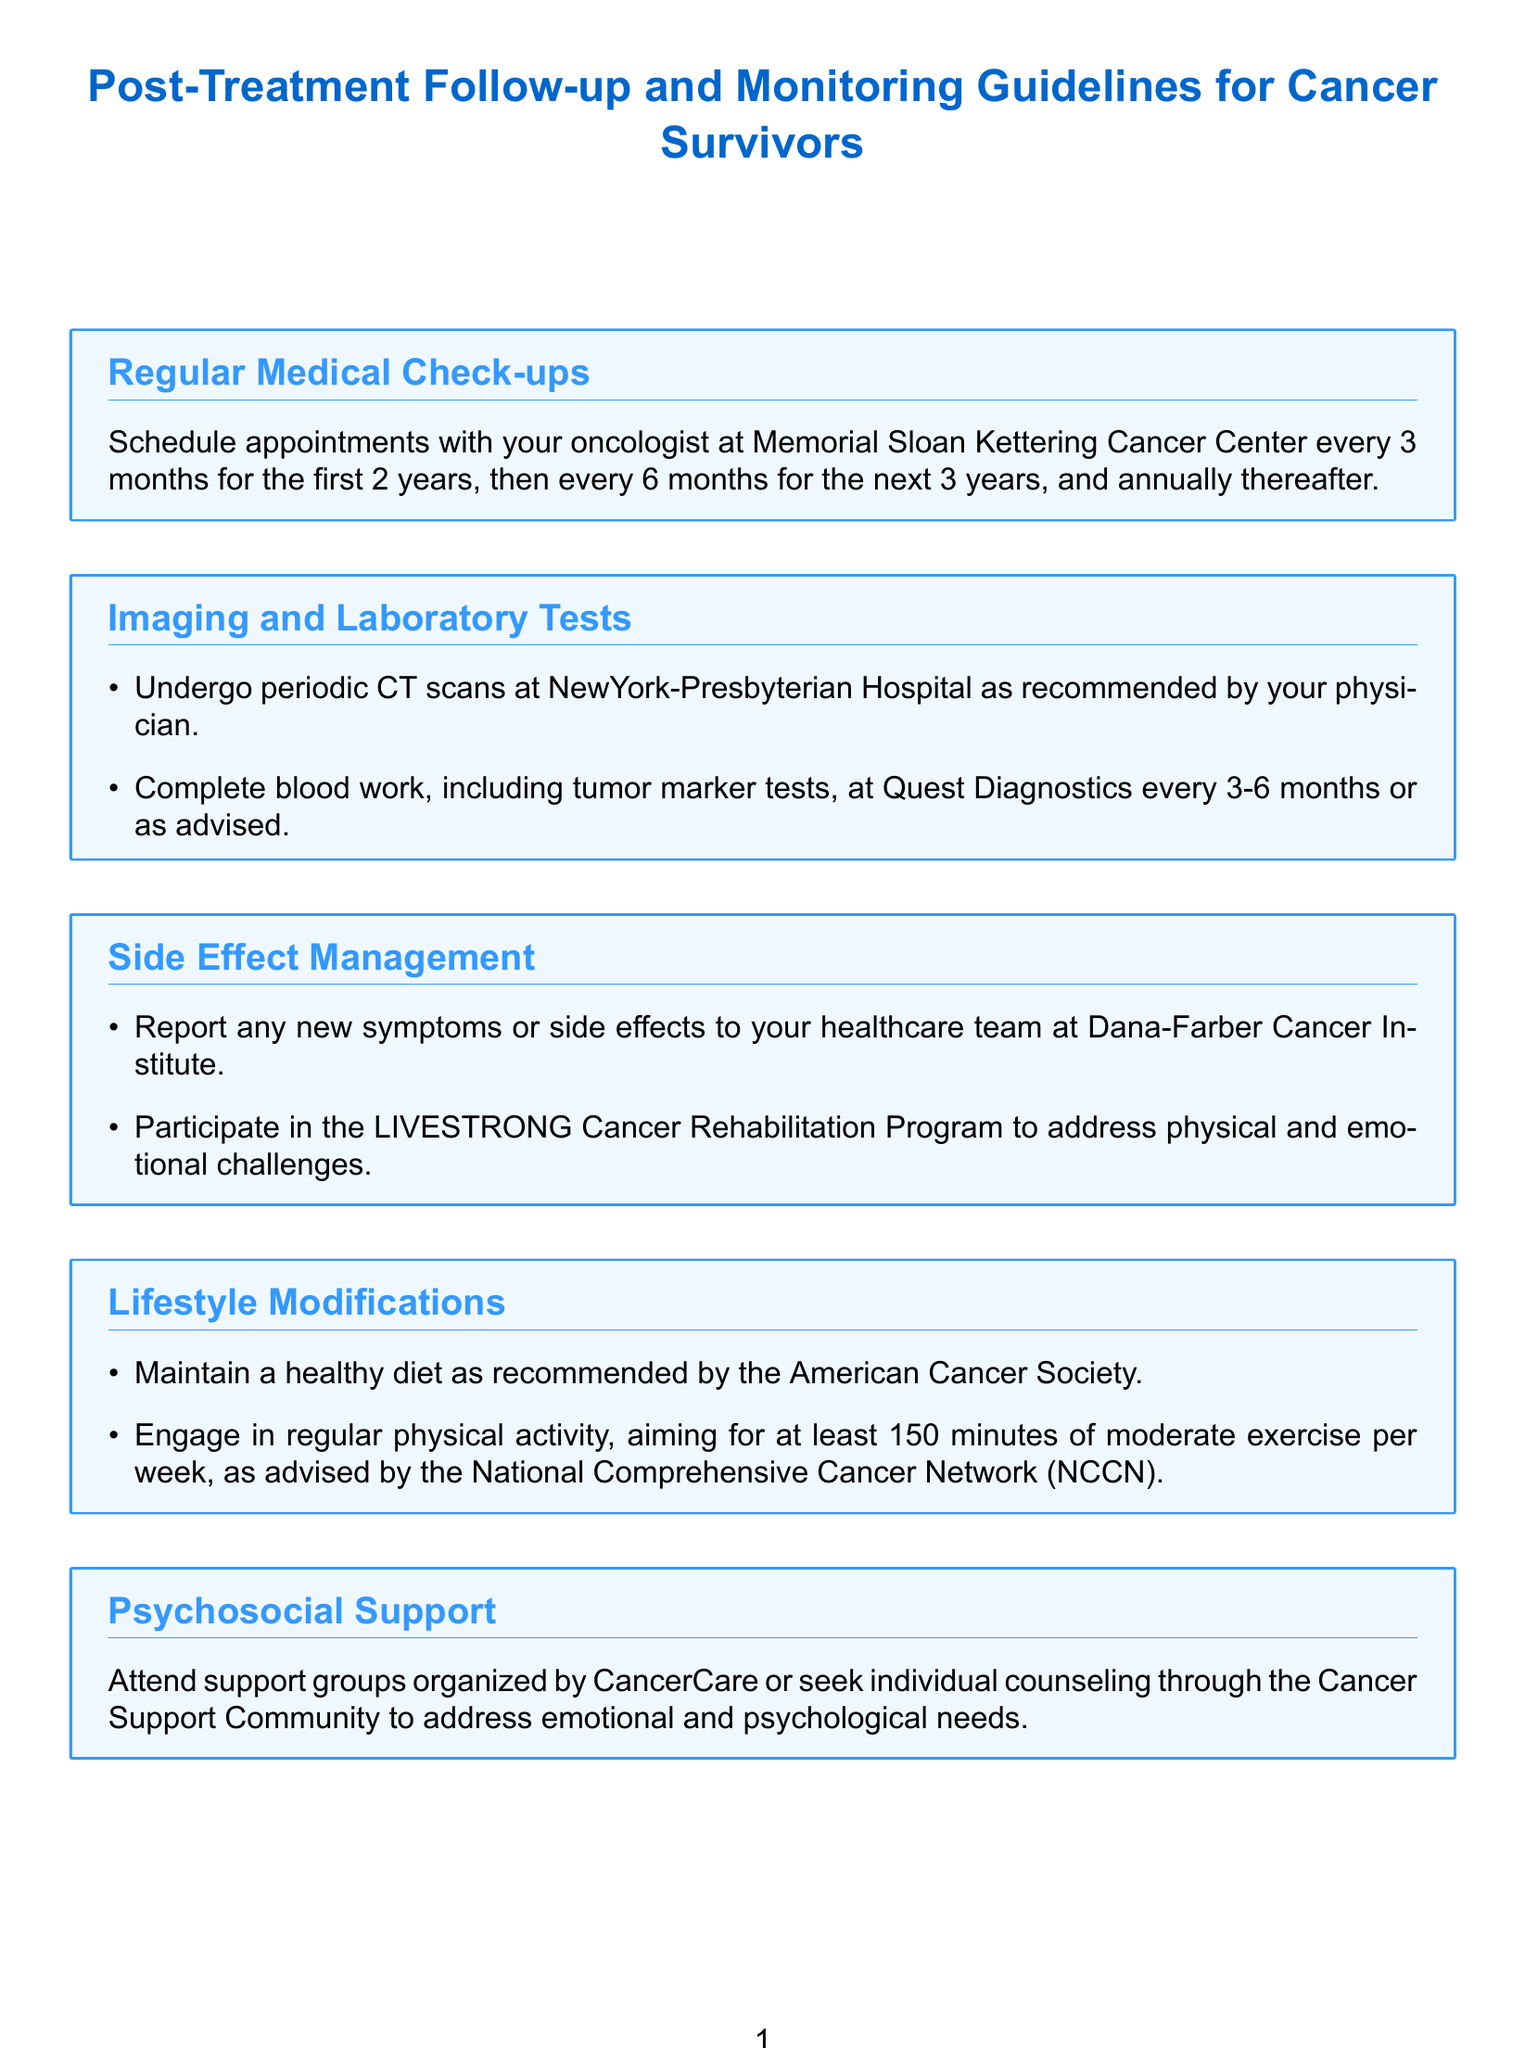What is the recommended frequency for medical check-ups in the first 2 years? The document specifies that appointments with the oncologist should be scheduled every 3 months for the first 2 years.
Answer: every 3 months Which facility is recommended for periodic CT scans? The document states that periodic CT scans should be undergone at NewYork-Presbyterian Hospital as recommended by the physician.
Answer: NewYork-Presbyterian Hospital How often should blood work, including tumor marker tests, be completed? Blood work, including tumor marker tests, should be done every 3-6 months or as advised.
Answer: every 3-6 months What program is suggested for managing physical and emotional challenges? The document recommends participating in the LIVESTRONG Cancer Rehabilitation Program for addressing physical and emotional challenges.
Answer: LIVESTRONG Cancer Rehabilitation Program What dietary recommendations does the document mention? The document suggests maintaining a healthy diet as recommended by the American Cancer Society.
Answer: healthy diet Which organization offers support groups for cancer survivors? The document mentions that support groups are organized by CancerCare for cancer survivors.
Answer: CancerCare What is the aim of engaging in physical activity according to the guidelines? The guidelines advise engaging in regular physical activity, aiming for at least 150 minutes of moderate exercise per week.
Answer: 150 minutes What should cancer survivors be vigilant for after treatment? The document emphasizes that survivors should be vigilant for signs of secondary cancers or late effects of treatment.
Answer: secondary cancers Which study can cancer survivors participate in to contribute to ongoing research? The document states that survivors can participate in the National Cancer Institute's Cancer Survivor Study.
Answer: National Cancer Institute's Cancer Survivor Study 